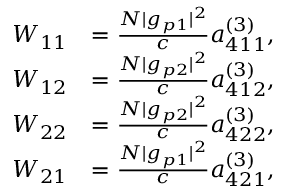Convert formula to latex. <formula><loc_0><loc_0><loc_500><loc_500>\begin{array} { r l } { W _ { 1 1 } } & { = \frac { N | g _ { p 1 } | ^ { 2 } } { c } a _ { 4 1 1 } ^ { ( 3 ) } , } \\ { W _ { 1 2 } } & { = \frac { N | g _ { p 2 } | ^ { 2 } } { c } a _ { 4 1 2 } ^ { ( 3 ) } , } \\ { W _ { 2 2 } } & { = \frac { N | g _ { p 2 } | ^ { 2 } } { c } a _ { 4 2 2 } ^ { ( 3 ) } , } \\ { W _ { 2 1 } } & { = \frac { N | g _ { p 1 } | ^ { 2 } } { c } a _ { 4 2 1 } ^ { ( 3 ) } , } \end{array}</formula> 